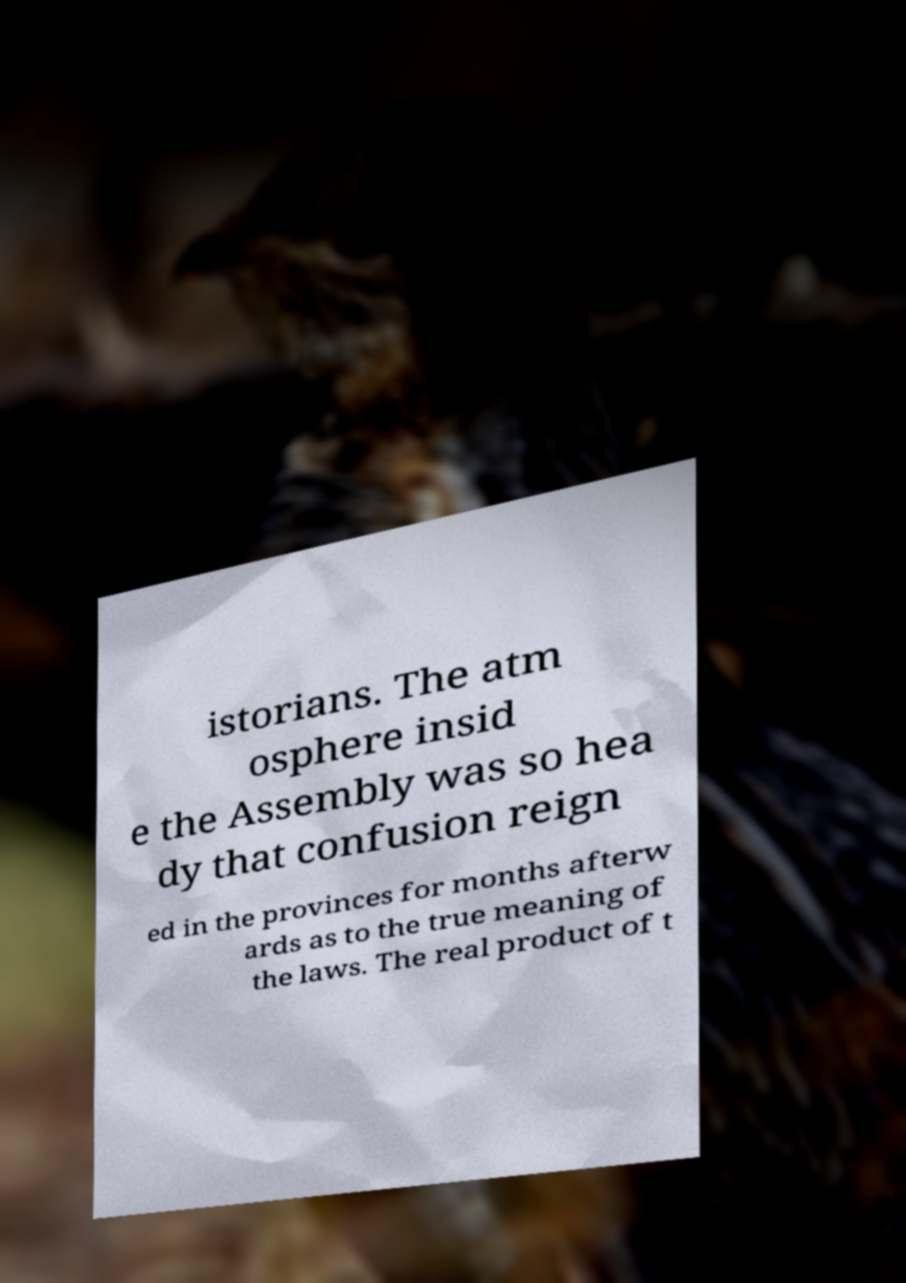There's text embedded in this image that I need extracted. Can you transcribe it verbatim? istorians. The atm osphere insid e the Assembly was so hea dy that confusion reign ed in the provinces for months afterw ards as to the true meaning of the laws. The real product of t 